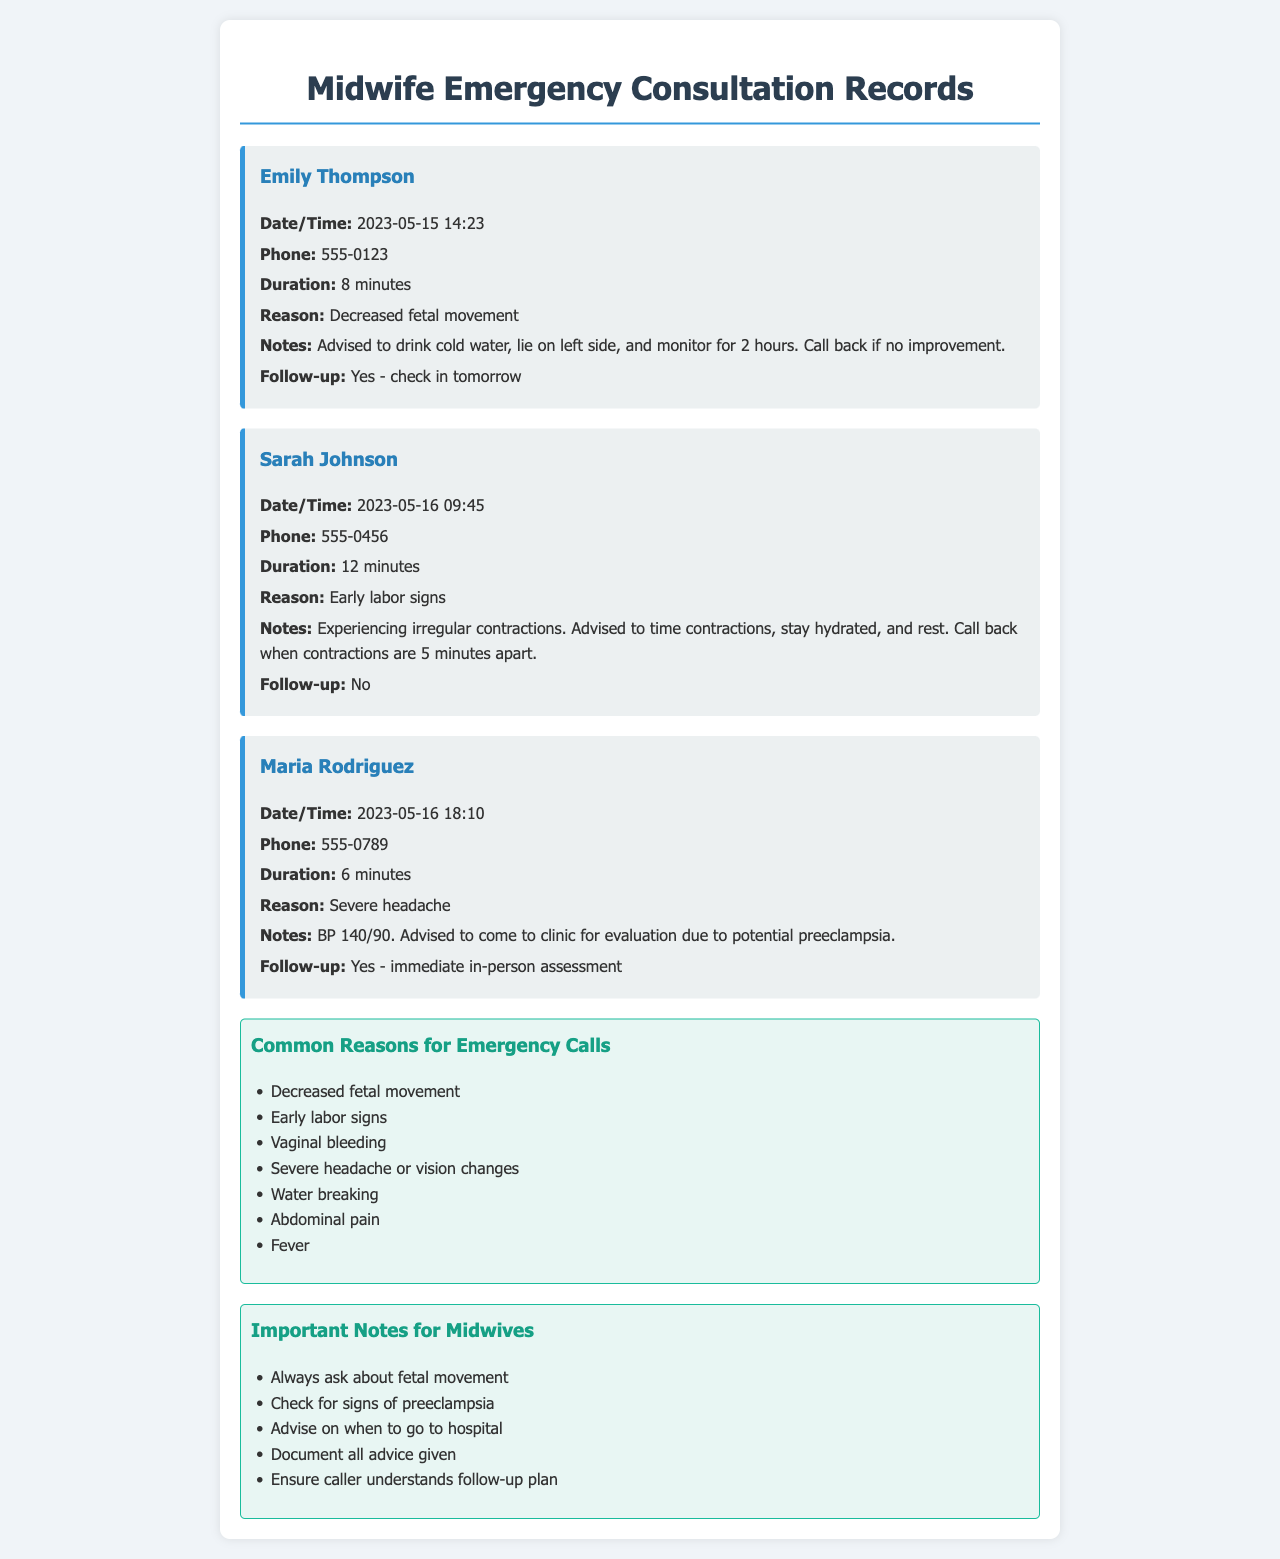What is the first name of the caller on May 15, 2023? The first name of the caller is found in the record for that date, which is Emily.
Answer: Emily What is the reason for Sarah Johnson's consultation? The reason can be found in her record, which states "Early labor signs."
Answer: Early labor signs What is the duration of Maria Rodriguez's call? The duration is specified in her record and is 6 minutes.
Answer: 6 minutes What follow-up action was advised for Emily Thompson? The follow-up action can be located in her record, which states "check in tomorrow."
Answer: check in tomorrow How many common reasons for emergency calls are listed? The total count of common reasons is found in the section labeled "Common Reasons for Emergency Calls," which lists 7 items.
Answer: 7 What was advised to do for the decreased fetal movement? The notes provide specific advice given to Emily, which includes "drink cold water, lie on left side, and monitor for 2 hours."
Answer: drink cold water, lie on left side, and monitor for 2 hours What blood pressure reading was noted for Maria Rodriguez? The reading is presented in her record and states "BP 140/90."
Answer: BP 140/90 Was a follow-up needed for Sarah Johnson? The follow-up status is noted in her record as "No."
Answer: No 